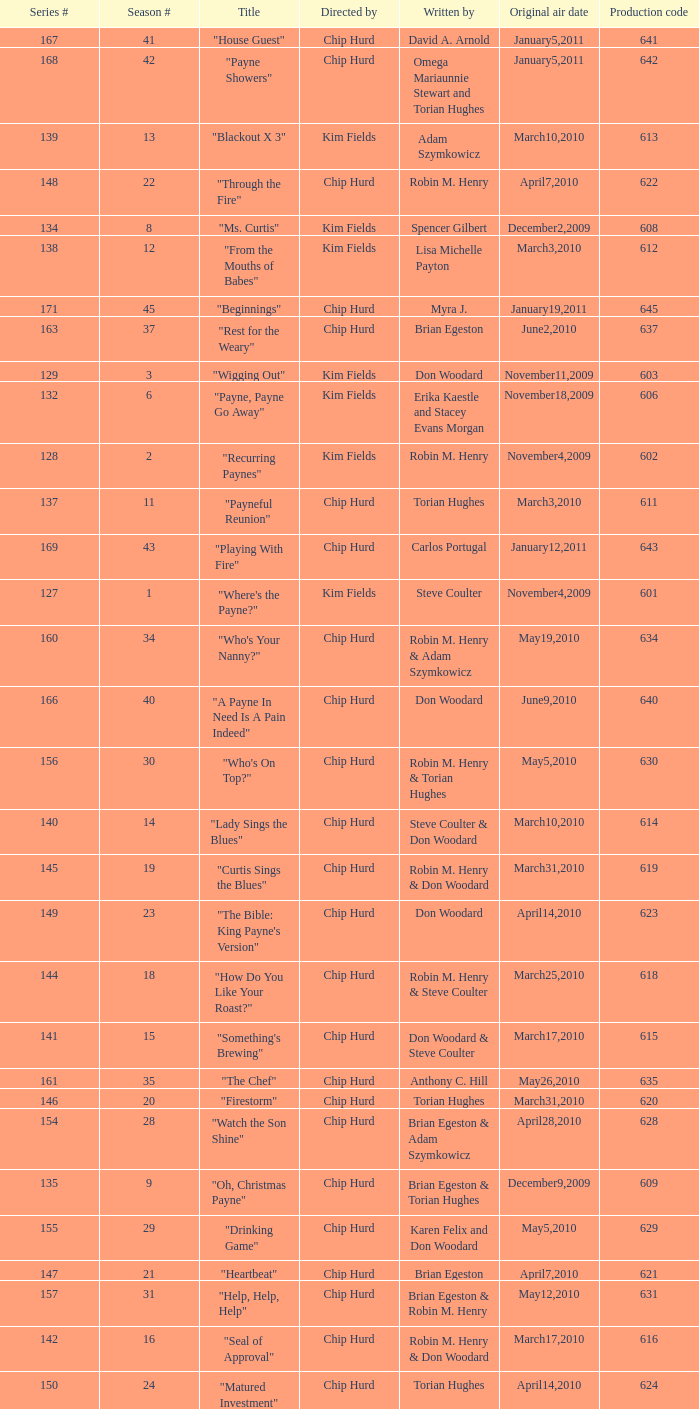What is the original air date of the episode written by Karen Felix and Don Woodard? May5,2010. 